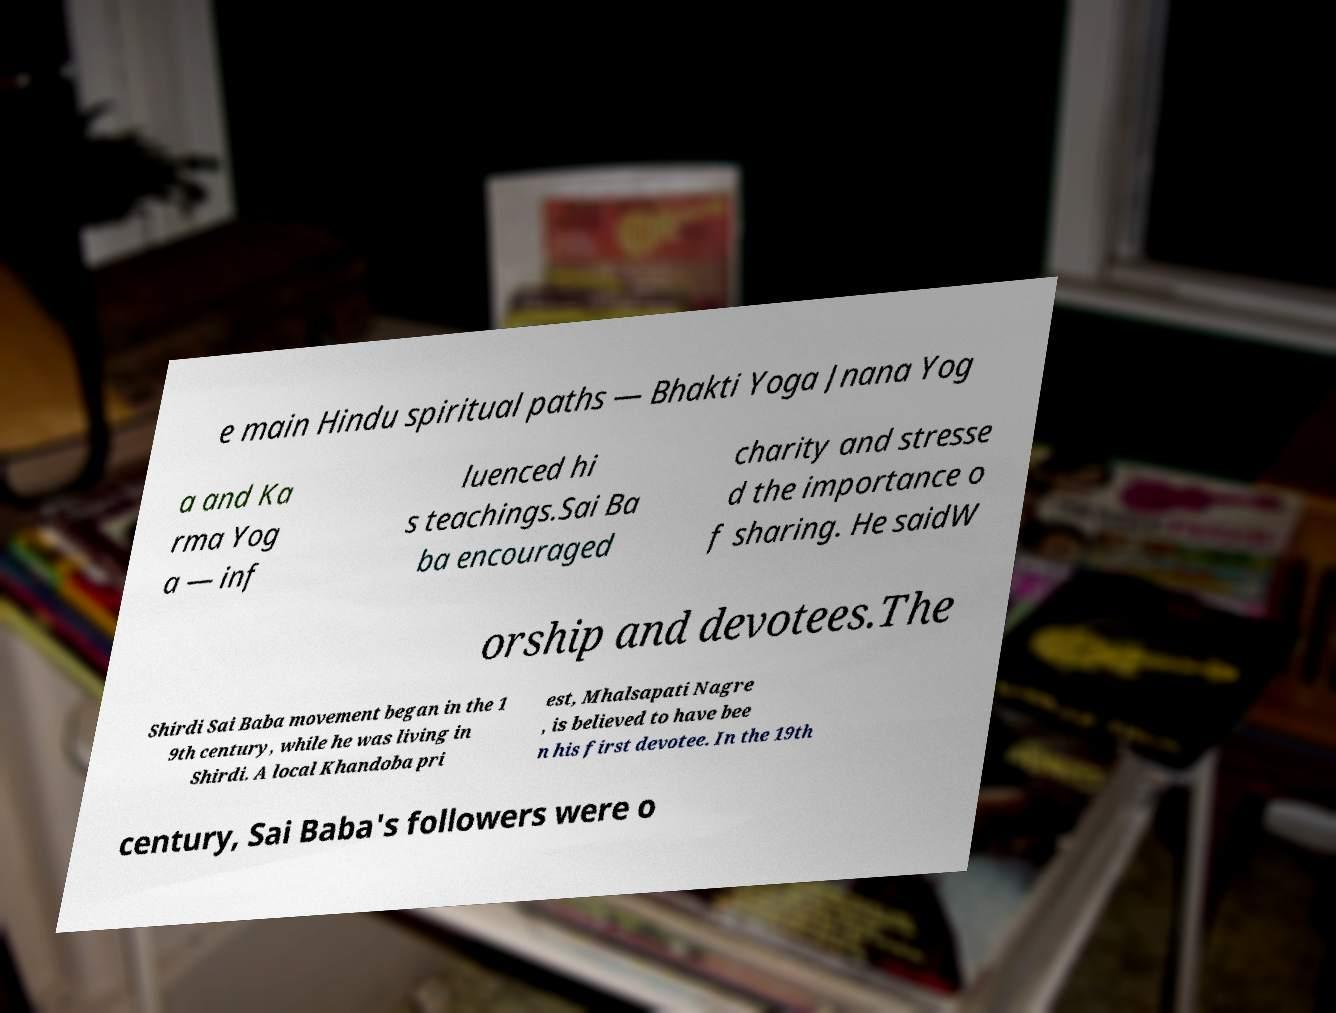Can you accurately transcribe the text from the provided image for me? e main Hindu spiritual paths — Bhakti Yoga Jnana Yog a and Ka rma Yog a — inf luenced hi s teachings.Sai Ba ba encouraged charity and stresse d the importance o f sharing. He saidW orship and devotees.The Shirdi Sai Baba movement began in the 1 9th century, while he was living in Shirdi. A local Khandoba pri est, Mhalsapati Nagre , is believed to have bee n his first devotee. In the 19th century, Sai Baba's followers were o 